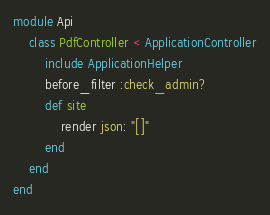Convert code to text. <code><loc_0><loc_0><loc_500><loc_500><_Ruby_>module Api
	class PdfController < ApplicationController
		include ApplicationHelper
		before_filter :check_admin?
		def site
			render json: "[]"
		end
	end
end
</code> 